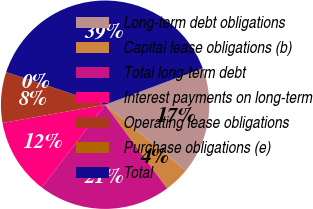Convert chart. <chart><loc_0><loc_0><loc_500><loc_500><pie_chart><fcel>Long-term debt obligations<fcel>Capital lease obligations (b)<fcel>Total long-term debt<fcel>Interest payments on long-term<fcel>Operating lease obligations<fcel>Purchase obligations (e)<fcel>Total<nl><fcel>16.61%<fcel>3.94%<fcel>20.54%<fcel>11.79%<fcel>7.86%<fcel>0.02%<fcel>39.24%<nl></chart> 